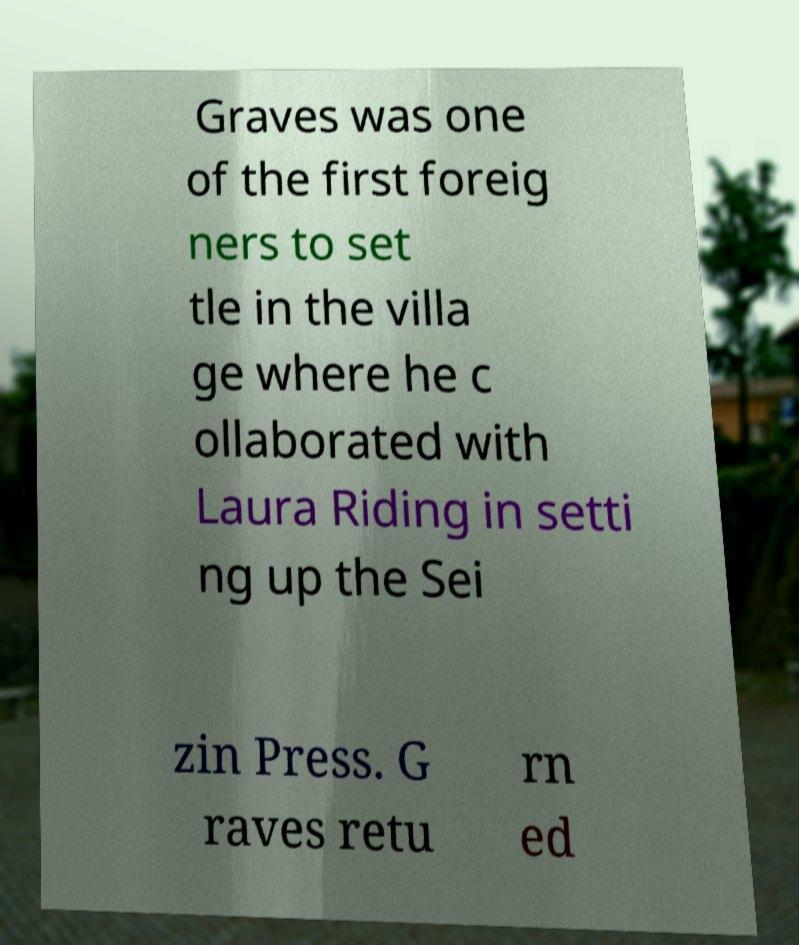Could you assist in decoding the text presented in this image and type it out clearly? Graves was one of the first foreig ners to set tle in the villa ge where he c ollaborated with Laura Riding in setti ng up the Sei zin Press. G raves retu rn ed 